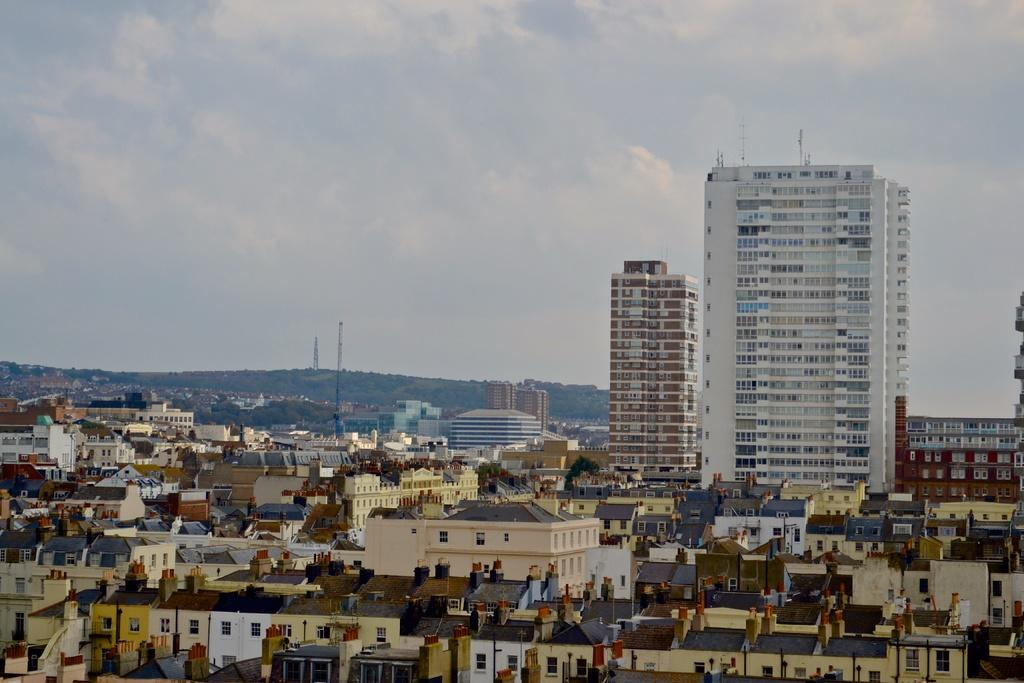What type of structures can be seen in the image? There are buildings in the image. How many poles are present in the image? There are 2 poles in the image. What can be seen in the background of the image? The sky is visible in the background of the image. What type of bomb is being defused in the image? There is no bomb present in the image; it only features buildings and poles. 